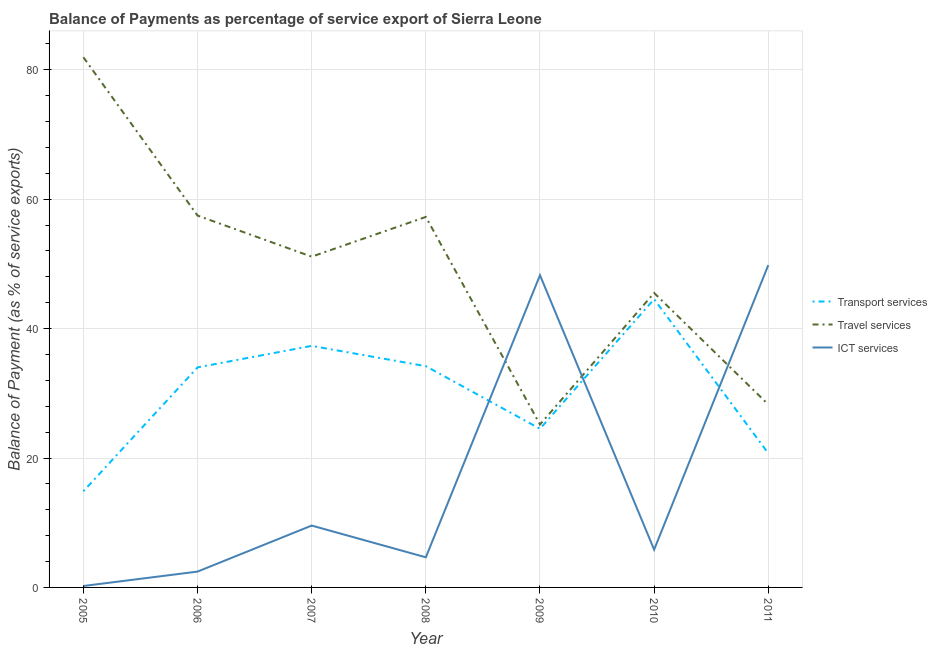How many different coloured lines are there?
Ensure brevity in your answer.  3. Does the line corresponding to balance of payment of ict services intersect with the line corresponding to balance of payment of transport services?
Ensure brevity in your answer.  Yes. What is the balance of payment of transport services in 2009?
Offer a terse response. 24.52. Across all years, what is the maximum balance of payment of transport services?
Keep it short and to the point. 44.56. Across all years, what is the minimum balance of payment of transport services?
Make the answer very short. 14.86. In which year was the balance of payment of travel services minimum?
Make the answer very short. 2009. What is the total balance of payment of ict services in the graph?
Offer a terse response. 120.79. What is the difference between the balance of payment of ict services in 2006 and that in 2007?
Your response must be concise. -7.11. What is the difference between the balance of payment of ict services in 2010 and the balance of payment of transport services in 2011?
Your answer should be very brief. -14.89. What is the average balance of payment of travel services per year?
Make the answer very short. 49.54. In the year 2009, what is the difference between the balance of payment of travel services and balance of payment of transport services?
Provide a succinct answer. 0.67. What is the ratio of the balance of payment of ict services in 2007 to that in 2011?
Your answer should be compact. 0.19. What is the difference between the highest and the second highest balance of payment of travel services?
Provide a succinct answer. 24.47. What is the difference between the highest and the lowest balance of payment of travel services?
Ensure brevity in your answer.  56.75. In how many years, is the balance of payment of ict services greater than the average balance of payment of ict services taken over all years?
Provide a succinct answer. 2. Is it the case that in every year, the sum of the balance of payment of transport services and balance of payment of travel services is greater than the balance of payment of ict services?
Offer a terse response. No. Is the balance of payment of travel services strictly greater than the balance of payment of ict services over the years?
Provide a succinct answer. No. Is the balance of payment of travel services strictly less than the balance of payment of transport services over the years?
Keep it short and to the point. No. How many years are there in the graph?
Your answer should be very brief. 7. What is the difference between two consecutive major ticks on the Y-axis?
Your answer should be very brief. 20. Are the values on the major ticks of Y-axis written in scientific E-notation?
Offer a terse response. No. Does the graph contain any zero values?
Make the answer very short. No. Does the graph contain grids?
Ensure brevity in your answer.  Yes. Where does the legend appear in the graph?
Your answer should be very brief. Center right. How are the legend labels stacked?
Give a very brief answer. Vertical. What is the title of the graph?
Your response must be concise. Balance of Payments as percentage of service export of Sierra Leone. Does "Slovak Republic" appear as one of the legend labels in the graph?
Ensure brevity in your answer.  No. What is the label or title of the Y-axis?
Give a very brief answer. Balance of Payment (as % of service exports). What is the Balance of Payment (as % of service exports) of Transport services in 2005?
Make the answer very short. 14.86. What is the Balance of Payment (as % of service exports) of Travel services in 2005?
Offer a terse response. 81.94. What is the Balance of Payment (as % of service exports) of ICT services in 2005?
Provide a short and direct response. 0.22. What is the Balance of Payment (as % of service exports) in Transport services in 2006?
Make the answer very short. 34.01. What is the Balance of Payment (as % of service exports) in Travel services in 2006?
Provide a succinct answer. 57.47. What is the Balance of Payment (as % of service exports) of ICT services in 2006?
Keep it short and to the point. 2.45. What is the Balance of Payment (as % of service exports) of Transport services in 2007?
Your answer should be compact. 37.33. What is the Balance of Payment (as % of service exports) of Travel services in 2007?
Offer a terse response. 51.12. What is the Balance of Payment (as % of service exports) of ICT services in 2007?
Offer a terse response. 9.56. What is the Balance of Payment (as % of service exports) of Transport services in 2008?
Provide a succinct answer. 34.2. What is the Balance of Payment (as % of service exports) in Travel services in 2008?
Offer a terse response. 57.26. What is the Balance of Payment (as % of service exports) in ICT services in 2008?
Give a very brief answer. 4.65. What is the Balance of Payment (as % of service exports) of Transport services in 2009?
Ensure brevity in your answer.  24.52. What is the Balance of Payment (as % of service exports) of Travel services in 2009?
Ensure brevity in your answer.  25.19. What is the Balance of Payment (as % of service exports) of ICT services in 2009?
Offer a terse response. 48.26. What is the Balance of Payment (as % of service exports) in Transport services in 2010?
Provide a short and direct response. 44.56. What is the Balance of Payment (as % of service exports) of Travel services in 2010?
Ensure brevity in your answer.  45.51. What is the Balance of Payment (as % of service exports) of ICT services in 2010?
Ensure brevity in your answer.  5.84. What is the Balance of Payment (as % of service exports) in Transport services in 2011?
Ensure brevity in your answer.  20.73. What is the Balance of Payment (as % of service exports) in Travel services in 2011?
Give a very brief answer. 28.27. What is the Balance of Payment (as % of service exports) in ICT services in 2011?
Provide a succinct answer. 49.81. Across all years, what is the maximum Balance of Payment (as % of service exports) in Transport services?
Provide a succinct answer. 44.56. Across all years, what is the maximum Balance of Payment (as % of service exports) in Travel services?
Your response must be concise. 81.94. Across all years, what is the maximum Balance of Payment (as % of service exports) in ICT services?
Provide a succinct answer. 49.81. Across all years, what is the minimum Balance of Payment (as % of service exports) in Transport services?
Your response must be concise. 14.86. Across all years, what is the minimum Balance of Payment (as % of service exports) of Travel services?
Offer a terse response. 25.19. Across all years, what is the minimum Balance of Payment (as % of service exports) of ICT services?
Your response must be concise. 0.22. What is the total Balance of Payment (as % of service exports) in Transport services in the graph?
Make the answer very short. 210.2. What is the total Balance of Payment (as % of service exports) of Travel services in the graph?
Your answer should be compact. 346.76. What is the total Balance of Payment (as % of service exports) in ICT services in the graph?
Offer a very short reply. 120.79. What is the difference between the Balance of Payment (as % of service exports) of Transport services in 2005 and that in 2006?
Offer a very short reply. -19.15. What is the difference between the Balance of Payment (as % of service exports) in Travel services in 2005 and that in 2006?
Provide a short and direct response. 24.47. What is the difference between the Balance of Payment (as % of service exports) in ICT services in 2005 and that in 2006?
Your response must be concise. -2.23. What is the difference between the Balance of Payment (as % of service exports) of Transport services in 2005 and that in 2007?
Ensure brevity in your answer.  -22.47. What is the difference between the Balance of Payment (as % of service exports) in Travel services in 2005 and that in 2007?
Your response must be concise. 30.82. What is the difference between the Balance of Payment (as % of service exports) of ICT services in 2005 and that in 2007?
Provide a short and direct response. -9.34. What is the difference between the Balance of Payment (as % of service exports) of Transport services in 2005 and that in 2008?
Your answer should be compact. -19.33. What is the difference between the Balance of Payment (as % of service exports) in Travel services in 2005 and that in 2008?
Your answer should be compact. 24.68. What is the difference between the Balance of Payment (as % of service exports) in ICT services in 2005 and that in 2008?
Ensure brevity in your answer.  -4.43. What is the difference between the Balance of Payment (as % of service exports) of Transport services in 2005 and that in 2009?
Give a very brief answer. -9.66. What is the difference between the Balance of Payment (as % of service exports) in Travel services in 2005 and that in 2009?
Your response must be concise. 56.75. What is the difference between the Balance of Payment (as % of service exports) in ICT services in 2005 and that in 2009?
Offer a very short reply. -48.03. What is the difference between the Balance of Payment (as % of service exports) in Transport services in 2005 and that in 2010?
Your response must be concise. -29.69. What is the difference between the Balance of Payment (as % of service exports) of Travel services in 2005 and that in 2010?
Offer a very short reply. 36.43. What is the difference between the Balance of Payment (as % of service exports) in ICT services in 2005 and that in 2010?
Keep it short and to the point. -5.62. What is the difference between the Balance of Payment (as % of service exports) of Transport services in 2005 and that in 2011?
Offer a terse response. -5.87. What is the difference between the Balance of Payment (as % of service exports) in Travel services in 2005 and that in 2011?
Provide a short and direct response. 53.67. What is the difference between the Balance of Payment (as % of service exports) of ICT services in 2005 and that in 2011?
Offer a terse response. -49.59. What is the difference between the Balance of Payment (as % of service exports) in Transport services in 2006 and that in 2007?
Ensure brevity in your answer.  -3.32. What is the difference between the Balance of Payment (as % of service exports) in Travel services in 2006 and that in 2007?
Provide a succinct answer. 6.35. What is the difference between the Balance of Payment (as % of service exports) of ICT services in 2006 and that in 2007?
Offer a very short reply. -7.11. What is the difference between the Balance of Payment (as % of service exports) of Transport services in 2006 and that in 2008?
Ensure brevity in your answer.  -0.19. What is the difference between the Balance of Payment (as % of service exports) of Travel services in 2006 and that in 2008?
Offer a very short reply. 0.21. What is the difference between the Balance of Payment (as % of service exports) in ICT services in 2006 and that in 2008?
Your answer should be compact. -2.21. What is the difference between the Balance of Payment (as % of service exports) of Transport services in 2006 and that in 2009?
Give a very brief answer. 9.49. What is the difference between the Balance of Payment (as % of service exports) of Travel services in 2006 and that in 2009?
Keep it short and to the point. 32.29. What is the difference between the Balance of Payment (as % of service exports) of ICT services in 2006 and that in 2009?
Ensure brevity in your answer.  -45.81. What is the difference between the Balance of Payment (as % of service exports) in Transport services in 2006 and that in 2010?
Keep it short and to the point. -10.55. What is the difference between the Balance of Payment (as % of service exports) of Travel services in 2006 and that in 2010?
Your answer should be very brief. 11.96. What is the difference between the Balance of Payment (as % of service exports) of ICT services in 2006 and that in 2010?
Offer a terse response. -3.39. What is the difference between the Balance of Payment (as % of service exports) in Transport services in 2006 and that in 2011?
Offer a terse response. 13.28. What is the difference between the Balance of Payment (as % of service exports) of Travel services in 2006 and that in 2011?
Provide a short and direct response. 29.2. What is the difference between the Balance of Payment (as % of service exports) of ICT services in 2006 and that in 2011?
Your answer should be compact. -47.37. What is the difference between the Balance of Payment (as % of service exports) of Transport services in 2007 and that in 2008?
Your answer should be very brief. 3.14. What is the difference between the Balance of Payment (as % of service exports) of Travel services in 2007 and that in 2008?
Your response must be concise. -6.14. What is the difference between the Balance of Payment (as % of service exports) in ICT services in 2007 and that in 2008?
Your response must be concise. 4.91. What is the difference between the Balance of Payment (as % of service exports) of Transport services in 2007 and that in 2009?
Ensure brevity in your answer.  12.81. What is the difference between the Balance of Payment (as % of service exports) in Travel services in 2007 and that in 2009?
Offer a terse response. 25.94. What is the difference between the Balance of Payment (as % of service exports) of ICT services in 2007 and that in 2009?
Keep it short and to the point. -38.69. What is the difference between the Balance of Payment (as % of service exports) in Transport services in 2007 and that in 2010?
Your answer should be compact. -7.22. What is the difference between the Balance of Payment (as % of service exports) in Travel services in 2007 and that in 2010?
Keep it short and to the point. 5.61. What is the difference between the Balance of Payment (as % of service exports) in ICT services in 2007 and that in 2010?
Provide a short and direct response. 3.72. What is the difference between the Balance of Payment (as % of service exports) in Transport services in 2007 and that in 2011?
Offer a very short reply. 16.6. What is the difference between the Balance of Payment (as % of service exports) of Travel services in 2007 and that in 2011?
Your response must be concise. 22.85. What is the difference between the Balance of Payment (as % of service exports) of ICT services in 2007 and that in 2011?
Your response must be concise. -40.25. What is the difference between the Balance of Payment (as % of service exports) of Transport services in 2008 and that in 2009?
Make the answer very short. 9.68. What is the difference between the Balance of Payment (as % of service exports) of Travel services in 2008 and that in 2009?
Offer a terse response. 32.08. What is the difference between the Balance of Payment (as % of service exports) in ICT services in 2008 and that in 2009?
Your answer should be very brief. -43.6. What is the difference between the Balance of Payment (as % of service exports) in Transport services in 2008 and that in 2010?
Offer a very short reply. -10.36. What is the difference between the Balance of Payment (as % of service exports) of Travel services in 2008 and that in 2010?
Provide a succinct answer. 11.75. What is the difference between the Balance of Payment (as % of service exports) of ICT services in 2008 and that in 2010?
Keep it short and to the point. -1.18. What is the difference between the Balance of Payment (as % of service exports) in Transport services in 2008 and that in 2011?
Your response must be concise. 13.47. What is the difference between the Balance of Payment (as % of service exports) of Travel services in 2008 and that in 2011?
Give a very brief answer. 28.99. What is the difference between the Balance of Payment (as % of service exports) in ICT services in 2008 and that in 2011?
Offer a very short reply. -45.16. What is the difference between the Balance of Payment (as % of service exports) of Transport services in 2009 and that in 2010?
Ensure brevity in your answer.  -20.04. What is the difference between the Balance of Payment (as % of service exports) in Travel services in 2009 and that in 2010?
Make the answer very short. -20.33. What is the difference between the Balance of Payment (as % of service exports) of ICT services in 2009 and that in 2010?
Give a very brief answer. 42.42. What is the difference between the Balance of Payment (as % of service exports) in Transport services in 2009 and that in 2011?
Provide a succinct answer. 3.79. What is the difference between the Balance of Payment (as % of service exports) in Travel services in 2009 and that in 2011?
Make the answer very short. -3.09. What is the difference between the Balance of Payment (as % of service exports) in ICT services in 2009 and that in 2011?
Your answer should be very brief. -1.56. What is the difference between the Balance of Payment (as % of service exports) in Transport services in 2010 and that in 2011?
Give a very brief answer. 23.83. What is the difference between the Balance of Payment (as % of service exports) in Travel services in 2010 and that in 2011?
Offer a very short reply. 17.24. What is the difference between the Balance of Payment (as % of service exports) in ICT services in 2010 and that in 2011?
Provide a succinct answer. -43.98. What is the difference between the Balance of Payment (as % of service exports) in Transport services in 2005 and the Balance of Payment (as % of service exports) in Travel services in 2006?
Offer a very short reply. -42.61. What is the difference between the Balance of Payment (as % of service exports) of Transport services in 2005 and the Balance of Payment (as % of service exports) of ICT services in 2006?
Ensure brevity in your answer.  12.41. What is the difference between the Balance of Payment (as % of service exports) in Travel services in 2005 and the Balance of Payment (as % of service exports) in ICT services in 2006?
Keep it short and to the point. 79.49. What is the difference between the Balance of Payment (as % of service exports) of Transport services in 2005 and the Balance of Payment (as % of service exports) of Travel services in 2007?
Offer a very short reply. -36.26. What is the difference between the Balance of Payment (as % of service exports) of Transport services in 2005 and the Balance of Payment (as % of service exports) of ICT services in 2007?
Ensure brevity in your answer.  5.3. What is the difference between the Balance of Payment (as % of service exports) in Travel services in 2005 and the Balance of Payment (as % of service exports) in ICT services in 2007?
Ensure brevity in your answer.  72.38. What is the difference between the Balance of Payment (as % of service exports) in Transport services in 2005 and the Balance of Payment (as % of service exports) in Travel services in 2008?
Your response must be concise. -42.4. What is the difference between the Balance of Payment (as % of service exports) of Transport services in 2005 and the Balance of Payment (as % of service exports) of ICT services in 2008?
Ensure brevity in your answer.  10.21. What is the difference between the Balance of Payment (as % of service exports) of Travel services in 2005 and the Balance of Payment (as % of service exports) of ICT services in 2008?
Your response must be concise. 77.29. What is the difference between the Balance of Payment (as % of service exports) of Transport services in 2005 and the Balance of Payment (as % of service exports) of Travel services in 2009?
Offer a terse response. -10.32. What is the difference between the Balance of Payment (as % of service exports) in Transport services in 2005 and the Balance of Payment (as % of service exports) in ICT services in 2009?
Provide a succinct answer. -33.39. What is the difference between the Balance of Payment (as % of service exports) of Travel services in 2005 and the Balance of Payment (as % of service exports) of ICT services in 2009?
Your response must be concise. 33.68. What is the difference between the Balance of Payment (as % of service exports) of Transport services in 2005 and the Balance of Payment (as % of service exports) of Travel services in 2010?
Provide a short and direct response. -30.65. What is the difference between the Balance of Payment (as % of service exports) of Transport services in 2005 and the Balance of Payment (as % of service exports) of ICT services in 2010?
Offer a very short reply. 9.02. What is the difference between the Balance of Payment (as % of service exports) in Travel services in 2005 and the Balance of Payment (as % of service exports) in ICT services in 2010?
Your response must be concise. 76.1. What is the difference between the Balance of Payment (as % of service exports) in Transport services in 2005 and the Balance of Payment (as % of service exports) in Travel services in 2011?
Provide a succinct answer. -13.41. What is the difference between the Balance of Payment (as % of service exports) in Transport services in 2005 and the Balance of Payment (as % of service exports) in ICT services in 2011?
Provide a succinct answer. -34.95. What is the difference between the Balance of Payment (as % of service exports) of Travel services in 2005 and the Balance of Payment (as % of service exports) of ICT services in 2011?
Your answer should be compact. 32.13. What is the difference between the Balance of Payment (as % of service exports) in Transport services in 2006 and the Balance of Payment (as % of service exports) in Travel services in 2007?
Make the answer very short. -17.11. What is the difference between the Balance of Payment (as % of service exports) in Transport services in 2006 and the Balance of Payment (as % of service exports) in ICT services in 2007?
Provide a succinct answer. 24.45. What is the difference between the Balance of Payment (as % of service exports) of Travel services in 2006 and the Balance of Payment (as % of service exports) of ICT services in 2007?
Offer a very short reply. 47.91. What is the difference between the Balance of Payment (as % of service exports) in Transport services in 2006 and the Balance of Payment (as % of service exports) in Travel services in 2008?
Your response must be concise. -23.25. What is the difference between the Balance of Payment (as % of service exports) of Transport services in 2006 and the Balance of Payment (as % of service exports) of ICT services in 2008?
Give a very brief answer. 29.35. What is the difference between the Balance of Payment (as % of service exports) of Travel services in 2006 and the Balance of Payment (as % of service exports) of ICT services in 2008?
Keep it short and to the point. 52.82. What is the difference between the Balance of Payment (as % of service exports) of Transport services in 2006 and the Balance of Payment (as % of service exports) of Travel services in 2009?
Your response must be concise. 8.82. What is the difference between the Balance of Payment (as % of service exports) in Transport services in 2006 and the Balance of Payment (as % of service exports) in ICT services in 2009?
Make the answer very short. -14.25. What is the difference between the Balance of Payment (as % of service exports) in Travel services in 2006 and the Balance of Payment (as % of service exports) in ICT services in 2009?
Give a very brief answer. 9.22. What is the difference between the Balance of Payment (as % of service exports) in Transport services in 2006 and the Balance of Payment (as % of service exports) in Travel services in 2010?
Ensure brevity in your answer.  -11.5. What is the difference between the Balance of Payment (as % of service exports) of Transport services in 2006 and the Balance of Payment (as % of service exports) of ICT services in 2010?
Provide a succinct answer. 28.17. What is the difference between the Balance of Payment (as % of service exports) in Travel services in 2006 and the Balance of Payment (as % of service exports) in ICT services in 2010?
Your answer should be very brief. 51.63. What is the difference between the Balance of Payment (as % of service exports) of Transport services in 2006 and the Balance of Payment (as % of service exports) of Travel services in 2011?
Provide a succinct answer. 5.74. What is the difference between the Balance of Payment (as % of service exports) of Transport services in 2006 and the Balance of Payment (as % of service exports) of ICT services in 2011?
Offer a terse response. -15.81. What is the difference between the Balance of Payment (as % of service exports) of Travel services in 2006 and the Balance of Payment (as % of service exports) of ICT services in 2011?
Give a very brief answer. 7.66. What is the difference between the Balance of Payment (as % of service exports) of Transport services in 2007 and the Balance of Payment (as % of service exports) of Travel services in 2008?
Give a very brief answer. -19.93. What is the difference between the Balance of Payment (as % of service exports) in Transport services in 2007 and the Balance of Payment (as % of service exports) in ICT services in 2008?
Give a very brief answer. 32.68. What is the difference between the Balance of Payment (as % of service exports) of Travel services in 2007 and the Balance of Payment (as % of service exports) of ICT services in 2008?
Ensure brevity in your answer.  46.47. What is the difference between the Balance of Payment (as % of service exports) of Transport services in 2007 and the Balance of Payment (as % of service exports) of Travel services in 2009?
Provide a short and direct response. 12.15. What is the difference between the Balance of Payment (as % of service exports) of Transport services in 2007 and the Balance of Payment (as % of service exports) of ICT services in 2009?
Your response must be concise. -10.92. What is the difference between the Balance of Payment (as % of service exports) in Travel services in 2007 and the Balance of Payment (as % of service exports) in ICT services in 2009?
Make the answer very short. 2.87. What is the difference between the Balance of Payment (as % of service exports) in Transport services in 2007 and the Balance of Payment (as % of service exports) in Travel services in 2010?
Give a very brief answer. -8.18. What is the difference between the Balance of Payment (as % of service exports) in Transport services in 2007 and the Balance of Payment (as % of service exports) in ICT services in 2010?
Provide a short and direct response. 31.49. What is the difference between the Balance of Payment (as % of service exports) in Travel services in 2007 and the Balance of Payment (as % of service exports) in ICT services in 2010?
Make the answer very short. 45.28. What is the difference between the Balance of Payment (as % of service exports) of Transport services in 2007 and the Balance of Payment (as % of service exports) of Travel services in 2011?
Your answer should be very brief. 9.06. What is the difference between the Balance of Payment (as % of service exports) of Transport services in 2007 and the Balance of Payment (as % of service exports) of ICT services in 2011?
Provide a short and direct response. -12.48. What is the difference between the Balance of Payment (as % of service exports) of Travel services in 2007 and the Balance of Payment (as % of service exports) of ICT services in 2011?
Your answer should be very brief. 1.31. What is the difference between the Balance of Payment (as % of service exports) in Transport services in 2008 and the Balance of Payment (as % of service exports) in Travel services in 2009?
Offer a very short reply. 9.01. What is the difference between the Balance of Payment (as % of service exports) of Transport services in 2008 and the Balance of Payment (as % of service exports) of ICT services in 2009?
Give a very brief answer. -14.06. What is the difference between the Balance of Payment (as % of service exports) in Travel services in 2008 and the Balance of Payment (as % of service exports) in ICT services in 2009?
Offer a terse response. 9.01. What is the difference between the Balance of Payment (as % of service exports) of Transport services in 2008 and the Balance of Payment (as % of service exports) of Travel services in 2010?
Offer a very short reply. -11.32. What is the difference between the Balance of Payment (as % of service exports) in Transport services in 2008 and the Balance of Payment (as % of service exports) in ICT services in 2010?
Provide a short and direct response. 28.36. What is the difference between the Balance of Payment (as % of service exports) of Travel services in 2008 and the Balance of Payment (as % of service exports) of ICT services in 2010?
Your answer should be compact. 51.42. What is the difference between the Balance of Payment (as % of service exports) of Transport services in 2008 and the Balance of Payment (as % of service exports) of Travel services in 2011?
Provide a short and direct response. 5.92. What is the difference between the Balance of Payment (as % of service exports) of Transport services in 2008 and the Balance of Payment (as % of service exports) of ICT services in 2011?
Provide a succinct answer. -15.62. What is the difference between the Balance of Payment (as % of service exports) of Travel services in 2008 and the Balance of Payment (as % of service exports) of ICT services in 2011?
Your answer should be compact. 7.45. What is the difference between the Balance of Payment (as % of service exports) in Transport services in 2009 and the Balance of Payment (as % of service exports) in Travel services in 2010?
Your answer should be very brief. -20.99. What is the difference between the Balance of Payment (as % of service exports) of Transport services in 2009 and the Balance of Payment (as % of service exports) of ICT services in 2010?
Offer a terse response. 18.68. What is the difference between the Balance of Payment (as % of service exports) of Travel services in 2009 and the Balance of Payment (as % of service exports) of ICT services in 2010?
Provide a short and direct response. 19.35. What is the difference between the Balance of Payment (as % of service exports) of Transport services in 2009 and the Balance of Payment (as % of service exports) of Travel services in 2011?
Offer a very short reply. -3.75. What is the difference between the Balance of Payment (as % of service exports) of Transport services in 2009 and the Balance of Payment (as % of service exports) of ICT services in 2011?
Provide a succinct answer. -25.3. What is the difference between the Balance of Payment (as % of service exports) of Travel services in 2009 and the Balance of Payment (as % of service exports) of ICT services in 2011?
Your response must be concise. -24.63. What is the difference between the Balance of Payment (as % of service exports) of Transport services in 2010 and the Balance of Payment (as % of service exports) of Travel services in 2011?
Offer a terse response. 16.28. What is the difference between the Balance of Payment (as % of service exports) of Transport services in 2010 and the Balance of Payment (as % of service exports) of ICT services in 2011?
Your answer should be very brief. -5.26. What is the difference between the Balance of Payment (as % of service exports) in Travel services in 2010 and the Balance of Payment (as % of service exports) in ICT services in 2011?
Ensure brevity in your answer.  -4.3. What is the average Balance of Payment (as % of service exports) in Transport services per year?
Your answer should be very brief. 30.03. What is the average Balance of Payment (as % of service exports) in Travel services per year?
Offer a terse response. 49.54. What is the average Balance of Payment (as % of service exports) of ICT services per year?
Your response must be concise. 17.26. In the year 2005, what is the difference between the Balance of Payment (as % of service exports) in Transport services and Balance of Payment (as % of service exports) in Travel services?
Give a very brief answer. -67.08. In the year 2005, what is the difference between the Balance of Payment (as % of service exports) in Transport services and Balance of Payment (as % of service exports) in ICT services?
Provide a short and direct response. 14.64. In the year 2005, what is the difference between the Balance of Payment (as % of service exports) in Travel services and Balance of Payment (as % of service exports) in ICT services?
Ensure brevity in your answer.  81.72. In the year 2006, what is the difference between the Balance of Payment (as % of service exports) of Transport services and Balance of Payment (as % of service exports) of Travel services?
Offer a terse response. -23.46. In the year 2006, what is the difference between the Balance of Payment (as % of service exports) in Transport services and Balance of Payment (as % of service exports) in ICT services?
Give a very brief answer. 31.56. In the year 2006, what is the difference between the Balance of Payment (as % of service exports) of Travel services and Balance of Payment (as % of service exports) of ICT services?
Give a very brief answer. 55.03. In the year 2007, what is the difference between the Balance of Payment (as % of service exports) in Transport services and Balance of Payment (as % of service exports) in Travel services?
Offer a very short reply. -13.79. In the year 2007, what is the difference between the Balance of Payment (as % of service exports) of Transport services and Balance of Payment (as % of service exports) of ICT services?
Give a very brief answer. 27.77. In the year 2007, what is the difference between the Balance of Payment (as % of service exports) in Travel services and Balance of Payment (as % of service exports) in ICT services?
Offer a very short reply. 41.56. In the year 2008, what is the difference between the Balance of Payment (as % of service exports) in Transport services and Balance of Payment (as % of service exports) in Travel services?
Provide a succinct answer. -23.07. In the year 2008, what is the difference between the Balance of Payment (as % of service exports) in Transport services and Balance of Payment (as % of service exports) in ICT services?
Provide a short and direct response. 29.54. In the year 2008, what is the difference between the Balance of Payment (as % of service exports) in Travel services and Balance of Payment (as % of service exports) in ICT services?
Ensure brevity in your answer.  52.61. In the year 2009, what is the difference between the Balance of Payment (as % of service exports) in Transport services and Balance of Payment (as % of service exports) in Travel services?
Give a very brief answer. -0.67. In the year 2009, what is the difference between the Balance of Payment (as % of service exports) in Transport services and Balance of Payment (as % of service exports) in ICT services?
Provide a succinct answer. -23.74. In the year 2009, what is the difference between the Balance of Payment (as % of service exports) in Travel services and Balance of Payment (as % of service exports) in ICT services?
Provide a short and direct response. -23.07. In the year 2010, what is the difference between the Balance of Payment (as % of service exports) in Transport services and Balance of Payment (as % of service exports) in Travel services?
Make the answer very short. -0.96. In the year 2010, what is the difference between the Balance of Payment (as % of service exports) in Transport services and Balance of Payment (as % of service exports) in ICT services?
Your response must be concise. 38.72. In the year 2010, what is the difference between the Balance of Payment (as % of service exports) of Travel services and Balance of Payment (as % of service exports) of ICT services?
Offer a very short reply. 39.67. In the year 2011, what is the difference between the Balance of Payment (as % of service exports) of Transport services and Balance of Payment (as % of service exports) of Travel services?
Offer a very short reply. -7.54. In the year 2011, what is the difference between the Balance of Payment (as % of service exports) in Transport services and Balance of Payment (as % of service exports) in ICT services?
Make the answer very short. -29.08. In the year 2011, what is the difference between the Balance of Payment (as % of service exports) of Travel services and Balance of Payment (as % of service exports) of ICT services?
Offer a terse response. -21.54. What is the ratio of the Balance of Payment (as % of service exports) in Transport services in 2005 to that in 2006?
Make the answer very short. 0.44. What is the ratio of the Balance of Payment (as % of service exports) of Travel services in 2005 to that in 2006?
Your answer should be very brief. 1.43. What is the ratio of the Balance of Payment (as % of service exports) in ICT services in 2005 to that in 2006?
Offer a very short reply. 0.09. What is the ratio of the Balance of Payment (as % of service exports) in Transport services in 2005 to that in 2007?
Provide a short and direct response. 0.4. What is the ratio of the Balance of Payment (as % of service exports) in Travel services in 2005 to that in 2007?
Keep it short and to the point. 1.6. What is the ratio of the Balance of Payment (as % of service exports) of ICT services in 2005 to that in 2007?
Make the answer very short. 0.02. What is the ratio of the Balance of Payment (as % of service exports) of Transport services in 2005 to that in 2008?
Give a very brief answer. 0.43. What is the ratio of the Balance of Payment (as % of service exports) in Travel services in 2005 to that in 2008?
Give a very brief answer. 1.43. What is the ratio of the Balance of Payment (as % of service exports) of ICT services in 2005 to that in 2008?
Your answer should be compact. 0.05. What is the ratio of the Balance of Payment (as % of service exports) in Transport services in 2005 to that in 2009?
Offer a very short reply. 0.61. What is the ratio of the Balance of Payment (as % of service exports) in Travel services in 2005 to that in 2009?
Ensure brevity in your answer.  3.25. What is the ratio of the Balance of Payment (as % of service exports) of ICT services in 2005 to that in 2009?
Offer a terse response. 0. What is the ratio of the Balance of Payment (as % of service exports) in Transport services in 2005 to that in 2010?
Provide a succinct answer. 0.33. What is the ratio of the Balance of Payment (as % of service exports) in Travel services in 2005 to that in 2010?
Provide a succinct answer. 1.8. What is the ratio of the Balance of Payment (as % of service exports) in ICT services in 2005 to that in 2010?
Provide a succinct answer. 0.04. What is the ratio of the Balance of Payment (as % of service exports) of Transport services in 2005 to that in 2011?
Your response must be concise. 0.72. What is the ratio of the Balance of Payment (as % of service exports) in Travel services in 2005 to that in 2011?
Provide a succinct answer. 2.9. What is the ratio of the Balance of Payment (as % of service exports) of ICT services in 2005 to that in 2011?
Provide a short and direct response. 0. What is the ratio of the Balance of Payment (as % of service exports) in Transport services in 2006 to that in 2007?
Give a very brief answer. 0.91. What is the ratio of the Balance of Payment (as % of service exports) of Travel services in 2006 to that in 2007?
Your response must be concise. 1.12. What is the ratio of the Balance of Payment (as % of service exports) in ICT services in 2006 to that in 2007?
Your answer should be very brief. 0.26. What is the ratio of the Balance of Payment (as % of service exports) in Travel services in 2006 to that in 2008?
Make the answer very short. 1. What is the ratio of the Balance of Payment (as % of service exports) in ICT services in 2006 to that in 2008?
Offer a very short reply. 0.53. What is the ratio of the Balance of Payment (as % of service exports) in Transport services in 2006 to that in 2009?
Offer a terse response. 1.39. What is the ratio of the Balance of Payment (as % of service exports) in Travel services in 2006 to that in 2009?
Give a very brief answer. 2.28. What is the ratio of the Balance of Payment (as % of service exports) of ICT services in 2006 to that in 2009?
Give a very brief answer. 0.05. What is the ratio of the Balance of Payment (as % of service exports) in Transport services in 2006 to that in 2010?
Your answer should be compact. 0.76. What is the ratio of the Balance of Payment (as % of service exports) of Travel services in 2006 to that in 2010?
Your answer should be very brief. 1.26. What is the ratio of the Balance of Payment (as % of service exports) of ICT services in 2006 to that in 2010?
Your answer should be very brief. 0.42. What is the ratio of the Balance of Payment (as % of service exports) of Transport services in 2006 to that in 2011?
Provide a short and direct response. 1.64. What is the ratio of the Balance of Payment (as % of service exports) in Travel services in 2006 to that in 2011?
Keep it short and to the point. 2.03. What is the ratio of the Balance of Payment (as % of service exports) of ICT services in 2006 to that in 2011?
Give a very brief answer. 0.05. What is the ratio of the Balance of Payment (as % of service exports) in Transport services in 2007 to that in 2008?
Offer a terse response. 1.09. What is the ratio of the Balance of Payment (as % of service exports) of Travel services in 2007 to that in 2008?
Ensure brevity in your answer.  0.89. What is the ratio of the Balance of Payment (as % of service exports) of ICT services in 2007 to that in 2008?
Your answer should be very brief. 2.05. What is the ratio of the Balance of Payment (as % of service exports) in Transport services in 2007 to that in 2009?
Provide a short and direct response. 1.52. What is the ratio of the Balance of Payment (as % of service exports) in Travel services in 2007 to that in 2009?
Your answer should be very brief. 2.03. What is the ratio of the Balance of Payment (as % of service exports) in ICT services in 2007 to that in 2009?
Ensure brevity in your answer.  0.2. What is the ratio of the Balance of Payment (as % of service exports) of Transport services in 2007 to that in 2010?
Your response must be concise. 0.84. What is the ratio of the Balance of Payment (as % of service exports) of Travel services in 2007 to that in 2010?
Your answer should be very brief. 1.12. What is the ratio of the Balance of Payment (as % of service exports) in ICT services in 2007 to that in 2010?
Offer a terse response. 1.64. What is the ratio of the Balance of Payment (as % of service exports) of Transport services in 2007 to that in 2011?
Offer a terse response. 1.8. What is the ratio of the Balance of Payment (as % of service exports) in Travel services in 2007 to that in 2011?
Provide a succinct answer. 1.81. What is the ratio of the Balance of Payment (as % of service exports) of ICT services in 2007 to that in 2011?
Your answer should be very brief. 0.19. What is the ratio of the Balance of Payment (as % of service exports) in Transport services in 2008 to that in 2009?
Ensure brevity in your answer.  1.39. What is the ratio of the Balance of Payment (as % of service exports) in Travel services in 2008 to that in 2009?
Provide a short and direct response. 2.27. What is the ratio of the Balance of Payment (as % of service exports) of ICT services in 2008 to that in 2009?
Give a very brief answer. 0.1. What is the ratio of the Balance of Payment (as % of service exports) in Transport services in 2008 to that in 2010?
Give a very brief answer. 0.77. What is the ratio of the Balance of Payment (as % of service exports) in Travel services in 2008 to that in 2010?
Offer a very short reply. 1.26. What is the ratio of the Balance of Payment (as % of service exports) of ICT services in 2008 to that in 2010?
Keep it short and to the point. 0.8. What is the ratio of the Balance of Payment (as % of service exports) in Transport services in 2008 to that in 2011?
Keep it short and to the point. 1.65. What is the ratio of the Balance of Payment (as % of service exports) in Travel services in 2008 to that in 2011?
Your answer should be compact. 2.03. What is the ratio of the Balance of Payment (as % of service exports) in ICT services in 2008 to that in 2011?
Your answer should be compact. 0.09. What is the ratio of the Balance of Payment (as % of service exports) in Transport services in 2009 to that in 2010?
Keep it short and to the point. 0.55. What is the ratio of the Balance of Payment (as % of service exports) of Travel services in 2009 to that in 2010?
Offer a very short reply. 0.55. What is the ratio of the Balance of Payment (as % of service exports) of ICT services in 2009 to that in 2010?
Provide a succinct answer. 8.27. What is the ratio of the Balance of Payment (as % of service exports) in Transport services in 2009 to that in 2011?
Give a very brief answer. 1.18. What is the ratio of the Balance of Payment (as % of service exports) in Travel services in 2009 to that in 2011?
Your answer should be compact. 0.89. What is the ratio of the Balance of Payment (as % of service exports) in ICT services in 2009 to that in 2011?
Make the answer very short. 0.97. What is the ratio of the Balance of Payment (as % of service exports) of Transport services in 2010 to that in 2011?
Your response must be concise. 2.15. What is the ratio of the Balance of Payment (as % of service exports) in Travel services in 2010 to that in 2011?
Give a very brief answer. 1.61. What is the ratio of the Balance of Payment (as % of service exports) in ICT services in 2010 to that in 2011?
Provide a short and direct response. 0.12. What is the difference between the highest and the second highest Balance of Payment (as % of service exports) in Transport services?
Provide a succinct answer. 7.22. What is the difference between the highest and the second highest Balance of Payment (as % of service exports) of Travel services?
Your answer should be very brief. 24.47. What is the difference between the highest and the second highest Balance of Payment (as % of service exports) in ICT services?
Ensure brevity in your answer.  1.56. What is the difference between the highest and the lowest Balance of Payment (as % of service exports) of Transport services?
Ensure brevity in your answer.  29.69. What is the difference between the highest and the lowest Balance of Payment (as % of service exports) of Travel services?
Keep it short and to the point. 56.75. What is the difference between the highest and the lowest Balance of Payment (as % of service exports) of ICT services?
Offer a very short reply. 49.59. 